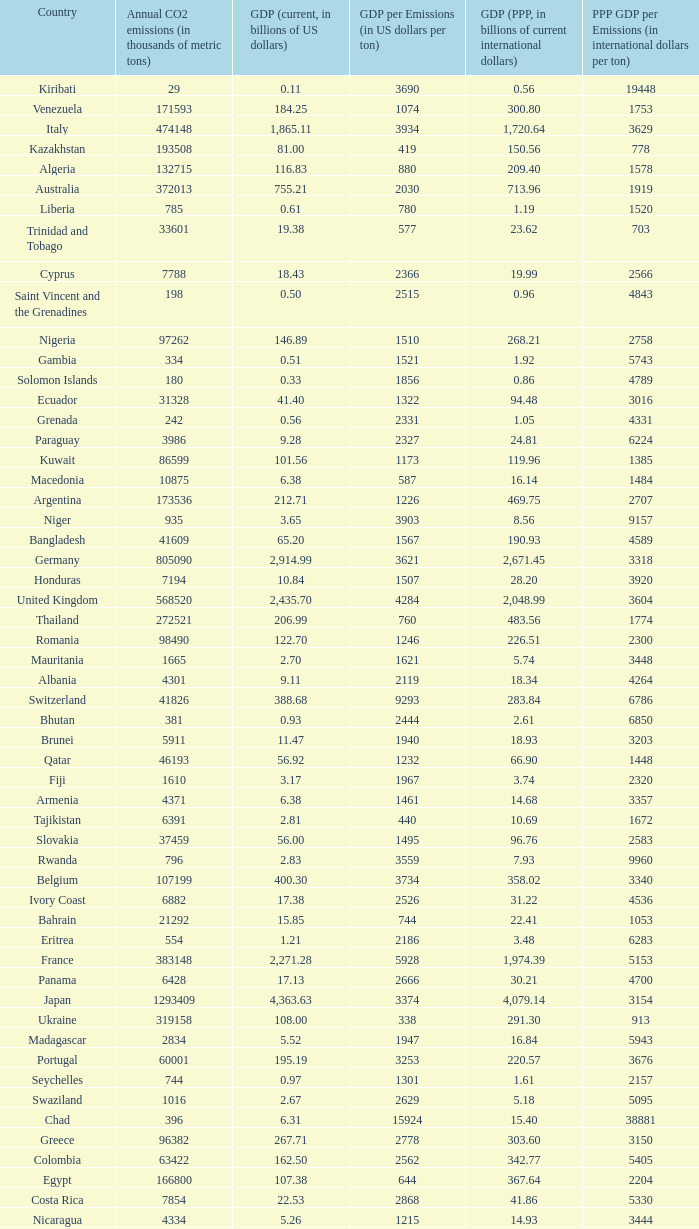When the gdp (current, in billions of us dollars) is 162.50, what is the gdp? 2562.0. 